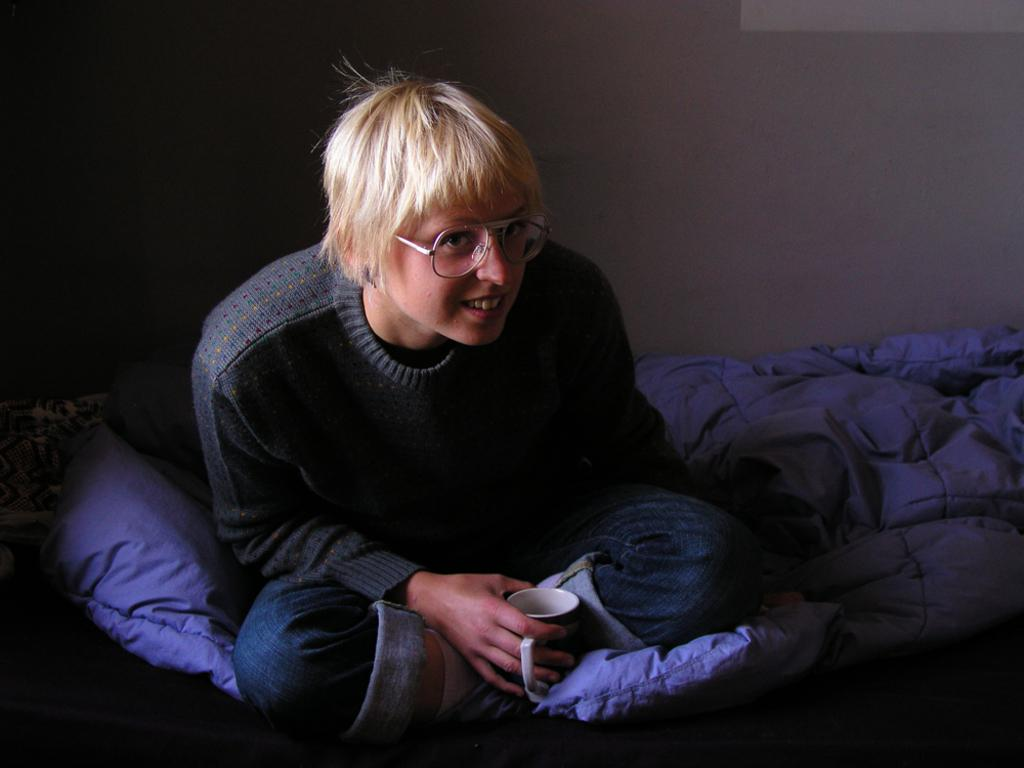What is the person in the image doing? The person is sitting on a couch in the image. What is the person holding while sitting on the couch? The person is holding a cup. What can be seen behind the person in the image? There is a wall visible in the background of the image. What color is the brother's shirt in the image? There is no brother present in the image, and therefore no shirt color can be determined. 